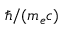Convert formula to latex. <formula><loc_0><loc_0><loc_500><loc_500>\hbar { / } ( m _ { e } c )</formula> 